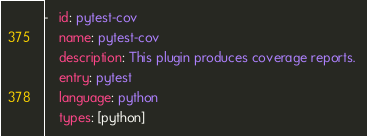Convert code to text. <code><loc_0><loc_0><loc_500><loc_500><_YAML_>-   id: pytest-cov
    name: pytest-cov
    description: This plugin produces coverage reports. 
    entry: pytest
    language: python
    types: [python]</code> 